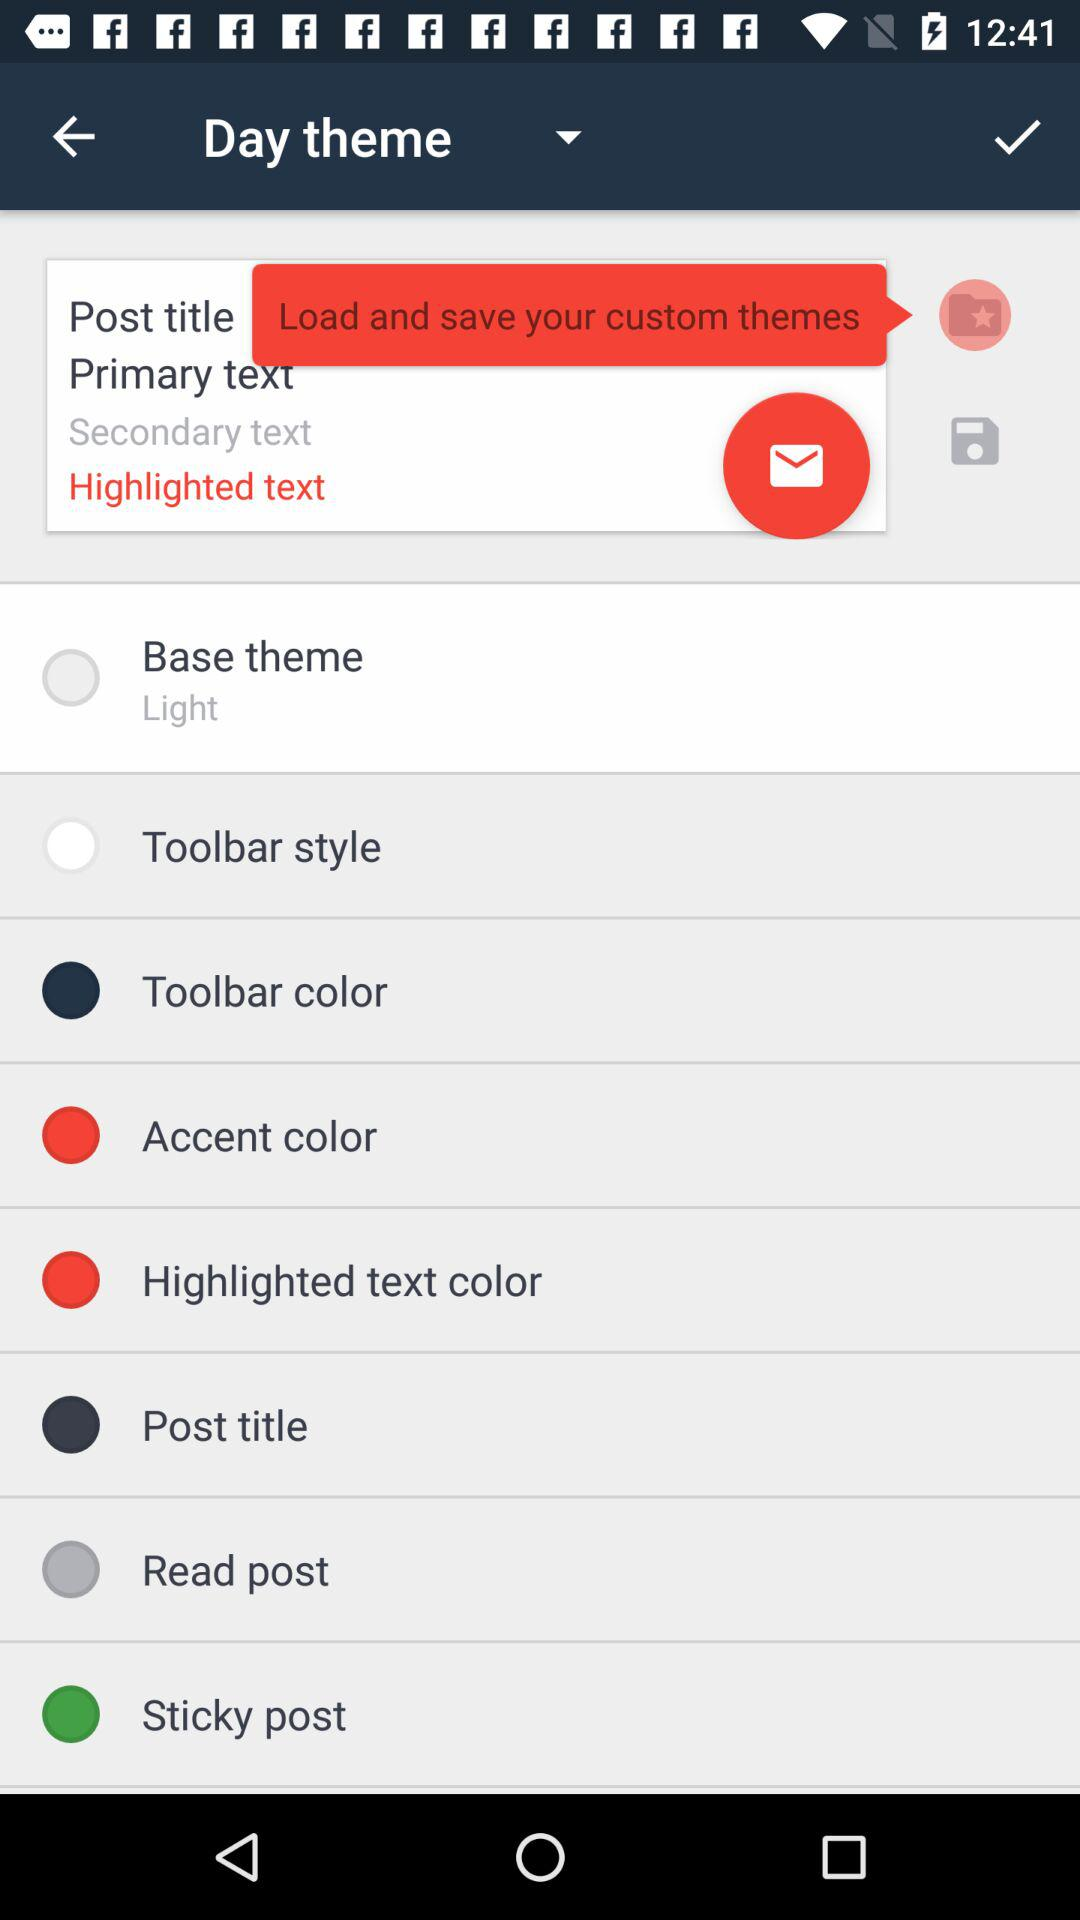Which theme is selected? The selected theme is "Base theme". 